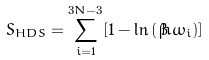<formula> <loc_0><loc_0><loc_500><loc_500>S _ { H D S } = \sum _ { i = 1 } ^ { 3 N - 3 } [ 1 - \ln \left ( \beta \hbar { \omega } _ { i } \right ) ]</formula> 